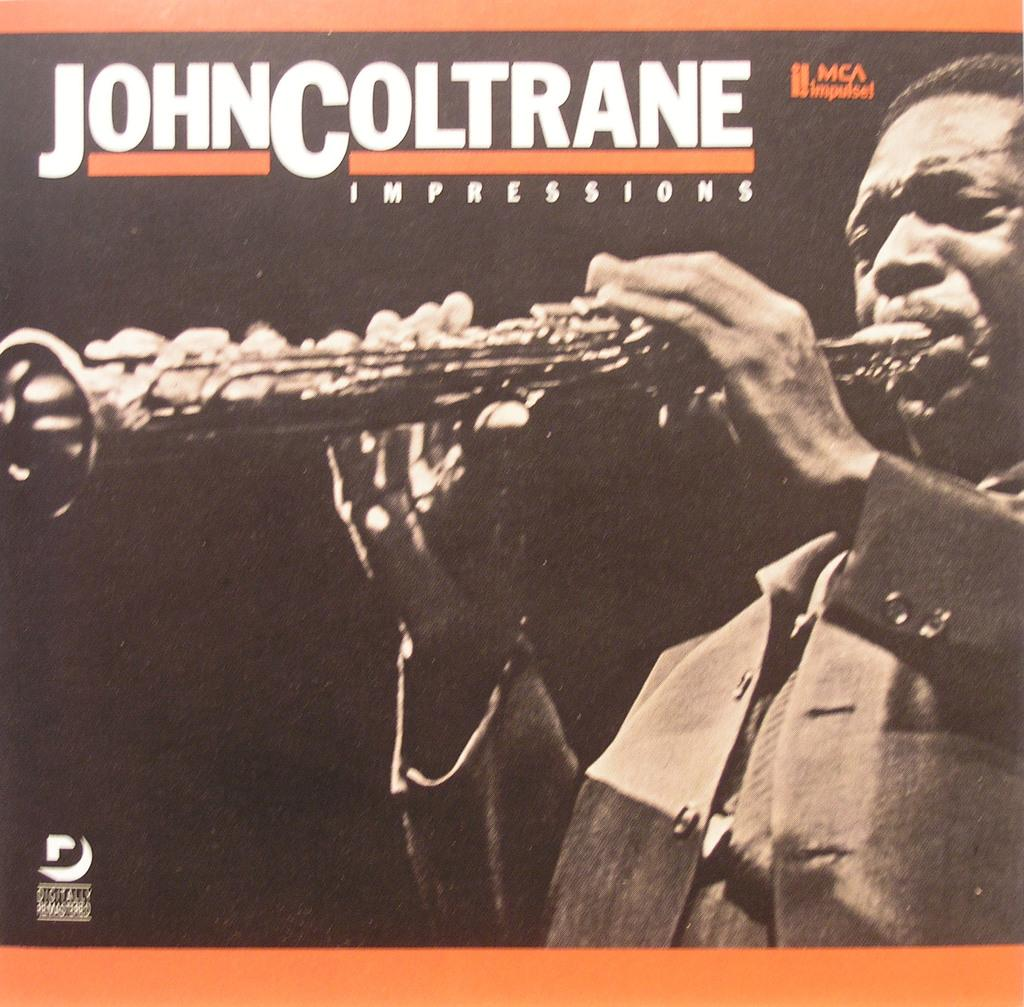What is the main subject of the image? The main subject of the image is a cover page. What is depicted on the cover page? The cover page features a man. What is the man doing in the image? The man is playing a musical instrument. What type of vessel is the man using to play the musical instrument in the image? There is no vessel present in the image; the man is playing the musical instrument without any visible vessel. What language is the man speaking while playing the musical instrument in the image? The image does not provide any information about the language being spoken, as it only shows the man playing the musical instrument. 